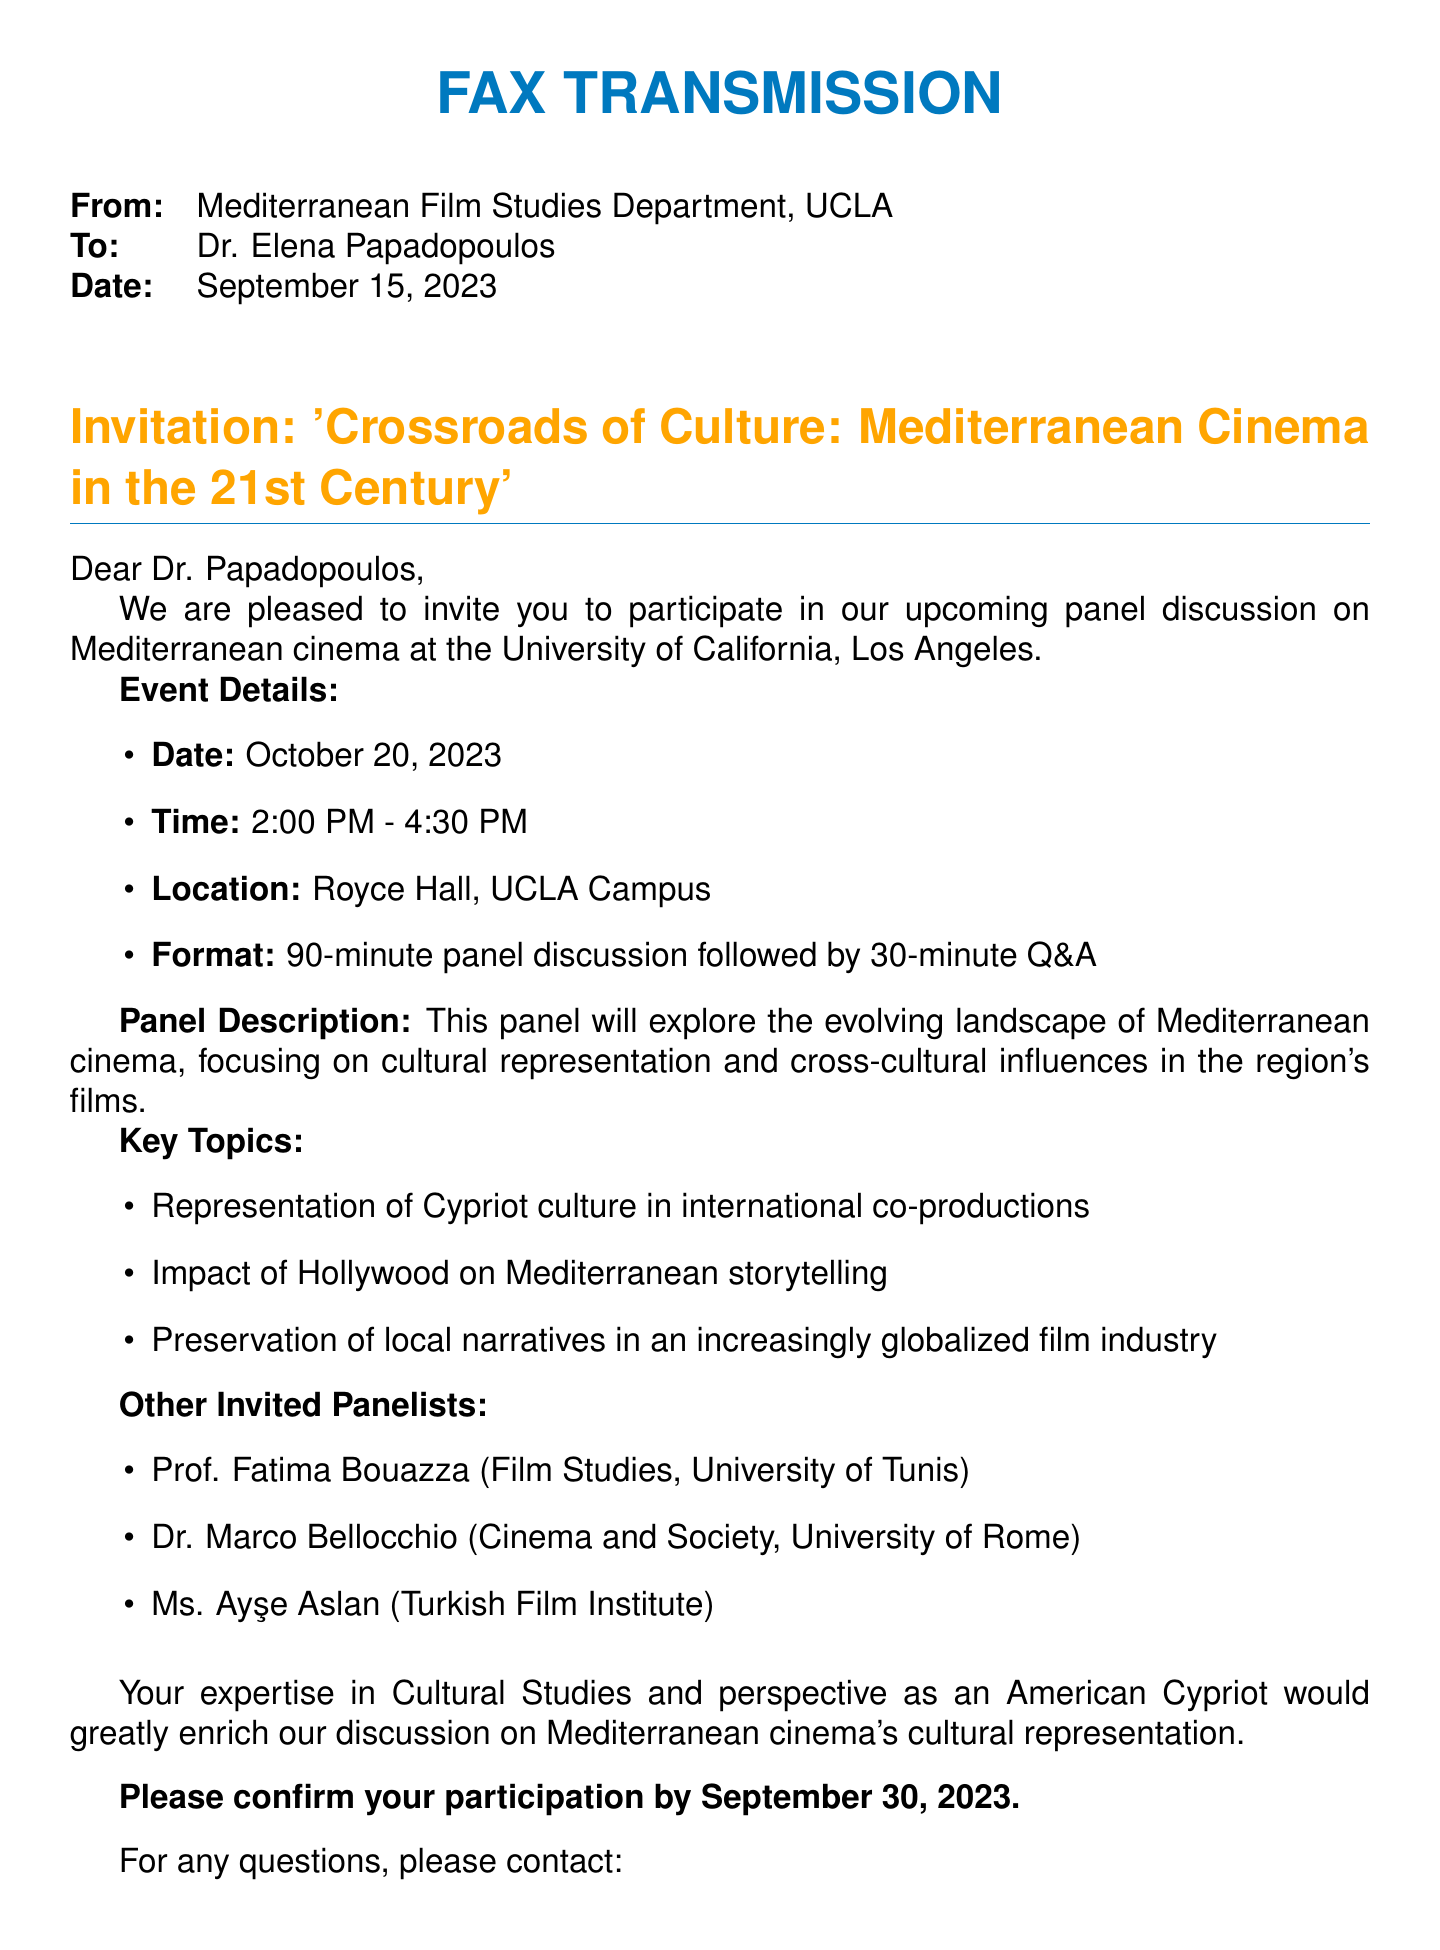What is the name of the panel discussion? The name of the panel discussion is provided in the title section of the document.
Answer: Crossroads of Culture: Mediterranean Cinema in the 21st Century Who is the invitation addressed to? The document specifies to whom the invitation is intended, found in the "To" section.
Answer: Dr. Elena Papadopoulos What is the date of the event? The event date is explicitly stated in the "Event Details" section of the document.
Answer: October 20, 2023 What time does the event start? The starting time is part of the event details, outlining the schedule.
Answer: 2:00 PM How long is the panel discussion scheduled to last? The document notes the structure of the event, including the duration of the panel discussion.
Answer: 90 minutes Who is the panel coordinator? The document provides the name of the individual coordinating the panel, found in the contact section.
Answer: Dr. Michael Thompson What is the last date to confirm participation? The document specifies the deadline for confirming participation.
Answer: September 30, 2023 What university is hosting the panel discussion? The hosting institution is mentioned at the top of the document.
Answer: University of California, Los Angeles What is one key topic listed for discussion? The document lists key topics being addressed in the panel discussion.
Answer: Representation of Cypriot culture in international co-productions 